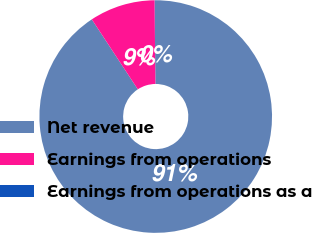Convert chart. <chart><loc_0><loc_0><loc_500><loc_500><pie_chart><fcel>Net revenue<fcel>Earnings from operations<fcel>Earnings from operations as a<nl><fcel>90.89%<fcel>9.1%<fcel>0.01%<nl></chart> 